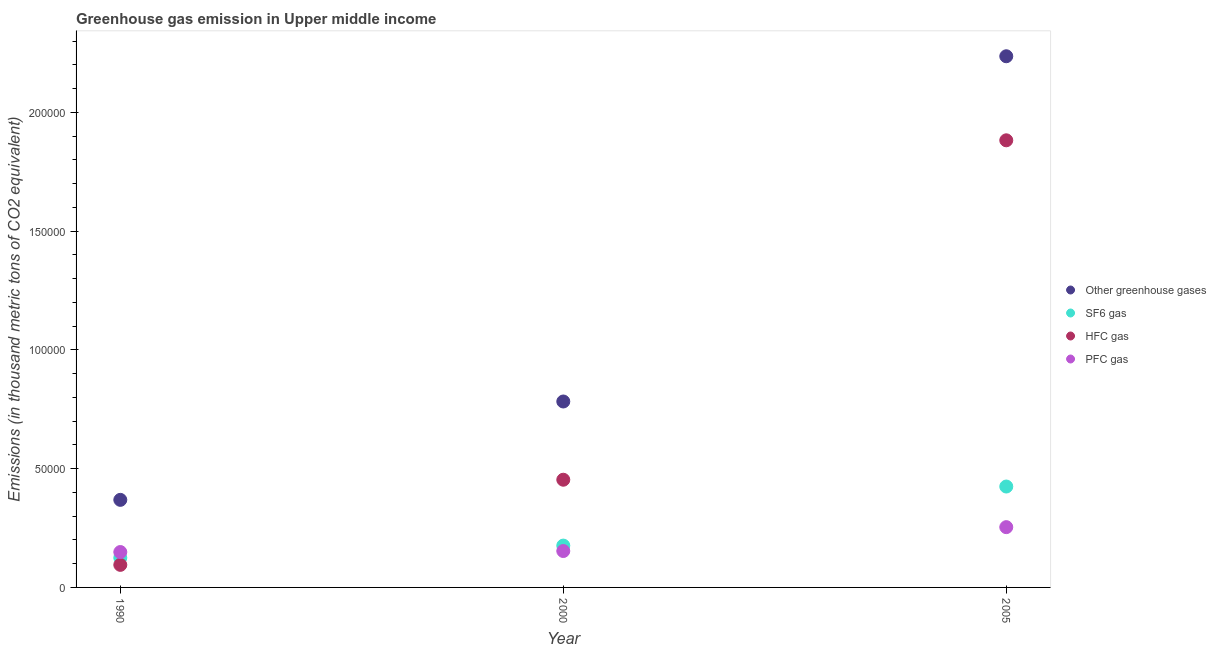How many different coloured dotlines are there?
Your answer should be compact. 4. What is the emission of hfc gas in 2005?
Keep it short and to the point. 1.88e+05. Across all years, what is the maximum emission of hfc gas?
Provide a short and direct response. 1.88e+05. Across all years, what is the minimum emission of hfc gas?
Provide a short and direct response. 9496.9. In which year was the emission of greenhouse gases minimum?
Offer a terse response. 1990. What is the total emission of greenhouse gases in the graph?
Ensure brevity in your answer.  3.39e+05. What is the difference between the emission of sf6 gas in 1990 and that in 2005?
Keep it short and to the point. -3.00e+04. What is the difference between the emission of hfc gas in 2000 and the emission of sf6 gas in 2005?
Your answer should be very brief. 2864.37. What is the average emission of hfc gas per year?
Make the answer very short. 8.10e+04. In the year 1990, what is the difference between the emission of pfc gas and emission of greenhouse gases?
Offer a very short reply. -2.20e+04. What is the ratio of the emission of sf6 gas in 1990 to that in 2005?
Provide a short and direct response. 0.29. Is the emission of pfc gas in 1990 less than that in 2000?
Offer a very short reply. Yes. Is the difference between the emission of hfc gas in 1990 and 2005 greater than the difference between the emission of pfc gas in 1990 and 2005?
Give a very brief answer. No. What is the difference between the highest and the second highest emission of pfc gas?
Provide a succinct answer. 1.01e+04. What is the difference between the highest and the lowest emission of hfc gas?
Your answer should be compact. 1.79e+05. In how many years, is the emission of greenhouse gases greater than the average emission of greenhouse gases taken over all years?
Offer a terse response. 1. Is the sum of the emission of hfc gas in 2000 and 2005 greater than the maximum emission of sf6 gas across all years?
Your answer should be very brief. Yes. Is it the case that in every year, the sum of the emission of hfc gas and emission of pfc gas is greater than the sum of emission of sf6 gas and emission of greenhouse gases?
Provide a short and direct response. No. Does the emission of sf6 gas monotonically increase over the years?
Your answer should be very brief. Yes. Is the emission of greenhouse gases strictly greater than the emission of sf6 gas over the years?
Your response must be concise. Yes. How many dotlines are there?
Provide a short and direct response. 4. How many years are there in the graph?
Ensure brevity in your answer.  3. What is the difference between two consecutive major ticks on the Y-axis?
Your answer should be very brief. 5.00e+04. Does the graph contain any zero values?
Keep it short and to the point. No. How many legend labels are there?
Give a very brief answer. 4. What is the title of the graph?
Give a very brief answer. Greenhouse gas emission in Upper middle income. What is the label or title of the Y-axis?
Provide a short and direct response. Emissions (in thousand metric tons of CO2 equivalent). What is the Emissions (in thousand metric tons of CO2 equivalent) of Other greenhouse gases in 1990?
Your answer should be very brief. 3.69e+04. What is the Emissions (in thousand metric tons of CO2 equivalent) of SF6 gas in 1990?
Offer a very short reply. 1.25e+04. What is the Emissions (in thousand metric tons of CO2 equivalent) in HFC gas in 1990?
Ensure brevity in your answer.  9496.9. What is the Emissions (in thousand metric tons of CO2 equivalent) in PFC gas in 1990?
Make the answer very short. 1.49e+04. What is the Emissions (in thousand metric tons of CO2 equivalent) in Other greenhouse gases in 2000?
Offer a very short reply. 7.83e+04. What is the Emissions (in thousand metric tons of CO2 equivalent) of SF6 gas in 2000?
Give a very brief answer. 1.76e+04. What is the Emissions (in thousand metric tons of CO2 equivalent) of HFC gas in 2000?
Your answer should be very brief. 4.53e+04. What is the Emissions (in thousand metric tons of CO2 equivalent) of PFC gas in 2000?
Your answer should be very brief. 1.53e+04. What is the Emissions (in thousand metric tons of CO2 equivalent) of Other greenhouse gases in 2005?
Offer a very short reply. 2.24e+05. What is the Emissions (in thousand metric tons of CO2 equivalent) in SF6 gas in 2005?
Provide a short and direct response. 4.25e+04. What is the Emissions (in thousand metric tons of CO2 equivalent) of HFC gas in 2005?
Your answer should be very brief. 1.88e+05. What is the Emissions (in thousand metric tons of CO2 equivalent) in PFC gas in 2005?
Provide a short and direct response. 2.54e+04. Across all years, what is the maximum Emissions (in thousand metric tons of CO2 equivalent) of Other greenhouse gases?
Keep it short and to the point. 2.24e+05. Across all years, what is the maximum Emissions (in thousand metric tons of CO2 equivalent) of SF6 gas?
Ensure brevity in your answer.  4.25e+04. Across all years, what is the maximum Emissions (in thousand metric tons of CO2 equivalent) of HFC gas?
Your response must be concise. 1.88e+05. Across all years, what is the maximum Emissions (in thousand metric tons of CO2 equivalent) in PFC gas?
Ensure brevity in your answer.  2.54e+04. Across all years, what is the minimum Emissions (in thousand metric tons of CO2 equivalent) in Other greenhouse gases?
Provide a short and direct response. 3.69e+04. Across all years, what is the minimum Emissions (in thousand metric tons of CO2 equivalent) of SF6 gas?
Keep it short and to the point. 1.25e+04. Across all years, what is the minimum Emissions (in thousand metric tons of CO2 equivalent) in HFC gas?
Provide a succinct answer. 9496.9. Across all years, what is the minimum Emissions (in thousand metric tons of CO2 equivalent) in PFC gas?
Ensure brevity in your answer.  1.49e+04. What is the total Emissions (in thousand metric tons of CO2 equivalent) of Other greenhouse gases in the graph?
Your response must be concise. 3.39e+05. What is the total Emissions (in thousand metric tons of CO2 equivalent) of SF6 gas in the graph?
Ensure brevity in your answer.  7.26e+04. What is the total Emissions (in thousand metric tons of CO2 equivalent) of HFC gas in the graph?
Give a very brief answer. 2.43e+05. What is the total Emissions (in thousand metric tons of CO2 equivalent) of PFC gas in the graph?
Provide a short and direct response. 5.56e+04. What is the difference between the Emissions (in thousand metric tons of CO2 equivalent) of Other greenhouse gases in 1990 and that in 2000?
Provide a short and direct response. -4.14e+04. What is the difference between the Emissions (in thousand metric tons of CO2 equivalent) in SF6 gas in 1990 and that in 2000?
Make the answer very short. -5140.8. What is the difference between the Emissions (in thousand metric tons of CO2 equivalent) of HFC gas in 1990 and that in 2000?
Keep it short and to the point. -3.58e+04. What is the difference between the Emissions (in thousand metric tons of CO2 equivalent) in PFC gas in 1990 and that in 2000?
Provide a succinct answer. -426.2. What is the difference between the Emissions (in thousand metric tons of CO2 equivalent) of Other greenhouse gases in 1990 and that in 2005?
Keep it short and to the point. -1.87e+05. What is the difference between the Emissions (in thousand metric tons of CO2 equivalent) of SF6 gas in 1990 and that in 2005?
Make the answer very short. -3.00e+04. What is the difference between the Emissions (in thousand metric tons of CO2 equivalent) in HFC gas in 1990 and that in 2005?
Your answer should be compact. -1.79e+05. What is the difference between the Emissions (in thousand metric tons of CO2 equivalent) in PFC gas in 1990 and that in 2005?
Keep it short and to the point. -1.05e+04. What is the difference between the Emissions (in thousand metric tons of CO2 equivalent) of Other greenhouse gases in 2000 and that in 2005?
Offer a terse response. -1.45e+05. What is the difference between the Emissions (in thousand metric tons of CO2 equivalent) in SF6 gas in 2000 and that in 2005?
Give a very brief answer. -2.49e+04. What is the difference between the Emissions (in thousand metric tons of CO2 equivalent) of HFC gas in 2000 and that in 2005?
Your answer should be compact. -1.43e+05. What is the difference between the Emissions (in thousand metric tons of CO2 equivalent) of PFC gas in 2000 and that in 2005?
Your response must be concise. -1.01e+04. What is the difference between the Emissions (in thousand metric tons of CO2 equivalent) of Other greenhouse gases in 1990 and the Emissions (in thousand metric tons of CO2 equivalent) of SF6 gas in 2000?
Your answer should be very brief. 1.93e+04. What is the difference between the Emissions (in thousand metric tons of CO2 equivalent) of Other greenhouse gases in 1990 and the Emissions (in thousand metric tons of CO2 equivalent) of HFC gas in 2000?
Make the answer very short. -8475.4. What is the difference between the Emissions (in thousand metric tons of CO2 equivalent) of Other greenhouse gases in 1990 and the Emissions (in thousand metric tons of CO2 equivalent) of PFC gas in 2000?
Keep it short and to the point. 2.15e+04. What is the difference between the Emissions (in thousand metric tons of CO2 equivalent) of SF6 gas in 1990 and the Emissions (in thousand metric tons of CO2 equivalent) of HFC gas in 2000?
Your answer should be compact. -3.29e+04. What is the difference between the Emissions (in thousand metric tons of CO2 equivalent) of SF6 gas in 1990 and the Emissions (in thousand metric tons of CO2 equivalent) of PFC gas in 2000?
Your response must be concise. -2856.3. What is the difference between the Emissions (in thousand metric tons of CO2 equivalent) in HFC gas in 1990 and the Emissions (in thousand metric tons of CO2 equivalent) in PFC gas in 2000?
Offer a terse response. -5829.9. What is the difference between the Emissions (in thousand metric tons of CO2 equivalent) of Other greenhouse gases in 1990 and the Emissions (in thousand metric tons of CO2 equivalent) of SF6 gas in 2005?
Make the answer very short. -5611.03. What is the difference between the Emissions (in thousand metric tons of CO2 equivalent) in Other greenhouse gases in 1990 and the Emissions (in thousand metric tons of CO2 equivalent) in HFC gas in 2005?
Make the answer very short. -1.51e+05. What is the difference between the Emissions (in thousand metric tons of CO2 equivalent) of Other greenhouse gases in 1990 and the Emissions (in thousand metric tons of CO2 equivalent) of PFC gas in 2005?
Your answer should be very brief. 1.15e+04. What is the difference between the Emissions (in thousand metric tons of CO2 equivalent) of SF6 gas in 1990 and the Emissions (in thousand metric tons of CO2 equivalent) of HFC gas in 2005?
Provide a succinct answer. -1.76e+05. What is the difference between the Emissions (in thousand metric tons of CO2 equivalent) in SF6 gas in 1990 and the Emissions (in thousand metric tons of CO2 equivalent) in PFC gas in 2005?
Give a very brief answer. -1.29e+04. What is the difference between the Emissions (in thousand metric tons of CO2 equivalent) in HFC gas in 1990 and the Emissions (in thousand metric tons of CO2 equivalent) in PFC gas in 2005?
Your answer should be compact. -1.59e+04. What is the difference between the Emissions (in thousand metric tons of CO2 equivalent) in Other greenhouse gases in 2000 and the Emissions (in thousand metric tons of CO2 equivalent) in SF6 gas in 2005?
Make the answer very short. 3.58e+04. What is the difference between the Emissions (in thousand metric tons of CO2 equivalent) in Other greenhouse gases in 2000 and the Emissions (in thousand metric tons of CO2 equivalent) in HFC gas in 2005?
Keep it short and to the point. -1.10e+05. What is the difference between the Emissions (in thousand metric tons of CO2 equivalent) of Other greenhouse gases in 2000 and the Emissions (in thousand metric tons of CO2 equivalent) of PFC gas in 2005?
Give a very brief answer. 5.29e+04. What is the difference between the Emissions (in thousand metric tons of CO2 equivalent) in SF6 gas in 2000 and the Emissions (in thousand metric tons of CO2 equivalent) in HFC gas in 2005?
Your response must be concise. -1.71e+05. What is the difference between the Emissions (in thousand metric tons of CO2 equivalent) of SF6 gas in 2000 and the Emissions (in thousand metric tons of CO2 equivalent) of PFC gas in 2005?
Your answer should be compact. -7766.13. What is the difference between the Emissions (in thousand metric tons of CO2 equivalent) of HFC gas in 2000 and the Emissions (in thousand metric tons of CO2 equivalent) of PFC gas in 2005?
Your answer should be compact. 2.00e+04. What is the average Emissions (in thousand metric tons of CO2 equivalent) of Other greenhouse gases per year?
Your answer should be compact. 1.13e+05. What is the average Emissions (in thousand metric tons of CO2 equivalent) in SF6 gas per year?
Provide a short and direct response. 2.42e+04. What is the average Emissions (in thousand metric tons of CO2 equivalent) in HFC gas per year?
Keep it short and to the point. 8.10e+04. What is the average Emissions (in thousand metric tons of CO2 equivalent) of PFC gas per year?
Provide a succinct answer. 1.85e+04. In the year 1990, what is the difference between the Emissions (in thousand metric tons of CO2 equivalent) of Other greenhouse gases and Emissions (in thousand metric tons of CO2 equivalent) of SF6 gas?
Provide a short and direct response. 2.44e+04. In the year 1990, what is the difference between the Emissions (in thousand metric tons of CO2 equivalent) in Other greenhouse gases and Emissions (in thousand metric tons of CO2 equivalent) in HFC gas?
Give a very brief answer. 2.74e+04. In the year 1990, what is the difference between the Emissions (in thousand metric tons of CO2 equivalent) of Other greenhouse gases and Emissions (in thousand metric tons of CO2 equivalent) of PFC gas?
Provide a short and direct response. 2.20e+04. In the year 1990, what is the difference between the Emissions (in thousand metric tons of CO2 equivalent) in SF6 gas and Emissions (in thousand metric tons of CO2 equivalent) in HFC gas?
Make the answer very short. 2973.6. In the year 1990, what is the difference between the Emissions (in thousand metric tons of CO2 equivalent) in SF6 gas and Emissions (in thousand metric tons of CO2 equivalent) in PFC gas?
Offer a very short reply. -2430.1. In the year 1990, what is the difference between the Emissions (in thousand metric tons of CO2 equivalent) in HFC gas and Emissions (in thousand metric tons of CO2 equivalent) in PFC gas?
Your answer should be compact. -5403.7. In the year 2000, what is the difference between the Emissions (in thousand metric tons of CO2 equivalent) in Other greenhouse gases and Emissions (in thousand metric tons of CO2 equivalent) in SF6 gas?
Make the answer very short. 6.07e+04. In the year 2000, what is the difference between the Emissions (in thousand metric tons of CO2 equivalent) in Other greenhouse gases and Emissions (in thousand metric tons of CO2 equivalent) in HFC gas?
Offer a very short reply. 3.29e+04. In the year 2000, what is the difference between the Emissions (in thousand metric tons of CO2 equivalent) of Other greenhouse gases and Emissions (in thousand metric tons of CO2 equivalent) of PFC gas?
Make the answer very short. 6.30e+04. In the year 2000, what is the difference between the Emissions (in thousand metric tons of CO2 equivalent) of SF6 gas and Emissions (in thousand metric tons of CO2 equivalent) of HFC gas?
Make the answer very short. -2.77e+04. In the year 2000, what is the difference between the Emissions (in thousand metric tons of CO2 equivalent) in SF6 gas and Emissions (in thousand metric tons of CO2 equivalent) in PFC gas?
Your answer should be compact. 2284.5. In the year 2000, what is the difference between the Emissions (in thousand metric tons of CO2 equivalent) in HFC gas and Emissions (in thousand metric tons of CO2 equivalent) in PFC gas?
Provide a succinct answer. 3.00e+04. In the year 2005, what is the difference between the Emissions (in thousand metric tons of CO2 equivalent) in Other greenhouse gases and Emissions (in thousand metric tons of CO2 equivalent) in SF6 gas?
Make the answer very short. 1.81e+05. In the year 2005, what is the difference between the Emissions (in thousand metric tons of CO2 equivalent) of Other greenhouse gases and Emissions (in thousand metric tons of CO2 equivalent) of HFC gas?
Provide a succinct answer. 3.54e+04. In the year 2005, what is the difference between the Emissions (in thousand metric tons of CO2 equivalent) in Other greenhouse gases and Emissions (in thousand metric tons of CO2 equivalent) in PFC gas?
Keep it short and to the point. 1.98e+05. In the year 2005, what is the difference between the Emissions (in thousand metric tons of CO2 equivalent) in SF6 gas and Emissions (in thousand metric tons of CO2 equivalent) in HFC gas?
Offer a very short reply. -1.46e+05. In the year 2005, what is the difference between the Emissions (in thousand metric tons of CO2 equivalent) of SF6 gas and Emissions (in thousand metric tons of CO2 equivalent) of PFC gas?
Provide a succinct answer. 1.71e+04. In the year 2005, what is the difference between the Emissions (in thousand metric tons of CO2 equivalent) of HFC gas and Emissions (in thousand metric tons of CO2 equivalent) of PFC gas?
Provide a succinct answer. 1.63e+05. What is the ratio of the Emissions (in thousand metric tons of CO2 equivalent) in Other greenhouse gases in 1990 to that in 2000?
Provide a succinct answer. 0.47. What is the ratio of the Emissions (in thousand metric tons of CO2 equivalent) in SF6 gas in 1990 to that in 2000?
Your answer should be compact. 0.71. What is the ratio of the Emissions (in thousand metric tons of CO2 equivalent) of HFC gas in 1990 to that in 2000?
Keep it short and to the point. 0.21. What is the ratio of the Emissions (in thousand metric tons of CO2 equivalent) of PFC gas in 1990 to that in 2000?
Offer a terse response. 0.97. What is the ratio of the Emissions (in thousand metric tons of CO2 equivalent) of Other greenhouse gases in 1990 to that in 2005?
Your answer should be compact. 0.16. What is the ratio of the Emissions (in thousand metric tons of CO2 equivalent) in SF6 gas in 1990 to that in 2005?
Your answer should be compact. 0.29. What is the ratio of the Emissions (in thousand metric tons of CO2 equivalent) of HFC gas in 1990 to that in 2005?
Your response must be concise. 0.05. What is the ratio of the Emissions (in thousand metric tons of CO2 equivalent) of PFC gas in 1990 to that in 2005?
Ensure brevity in your answer.  0.59. What is the ratio of the Emissions (in thousand metric tons of CO2 equivalent) in Other greenhouse gases in 2000 to that in 2005?
Ensure brevity in your answer.  0.35. What is the ratio of the Emissions (in thousand metric tons of CO2 equivalent) of SF6 gas in 2000 to that in 2005?
Ensure brevity in your answer.  0.41. What is the ratio of the Emissions (in thousand metric tons of CO2 equivalent) of HFC gas in 2000 to that in 2005?
Your answer should be very brief. 0.24. What is the ratio of the Emissions (in thousand metric tons of CO2 equivalent) of PFC gas in 2000 to that in 2005?
Provide a short and direct response. 0.6. What is the difference between the highest and the second highest Emissions (in thousand metric tons of CO2 equivalent) of Other greenhouse gases?
Make the answer very short. 1.45e+05. What is the difference between the highest and the second highest Emissions (in thousand metric tons of CO2 equivalent) in SF6 gas?
Offer a terse response. 2.49e+04. What is the difference between the highest and the second highest Emissions (in thousand metric tons of CO2 equivalent) in HFC gas?
Provide a succinct answer. 1.43e+05. What is the difference between the highest and the second highest Emissions (in thousand metric tons of CO2 equivalent) of PFC gas?
Your answer should be compact. 1.01e+04. What is the difference between the highest and the lowest Emissions (in thousand metric tons of CO2 equivalent) of Other greenhouse gases?
Keep it short and to the point. 1.87e+05. What is the difference between the highest and the lowest Emissions (in thousand metric tons of CO2 equivalent) of SF6 gas?
Provide a succinct answer. 3.00e+04. What is the difference between the highest and the lowest Emissions (in thousand metric tons of CO2 equivalent) of HFC gas?
Your answer should be compact. 1.79e+05. What is the difference between the highest and the lowest Emissions (in thousand metric tons of CO2 equivalent) in PFC gas?
Give a very brief answer. 1.05e+04. 